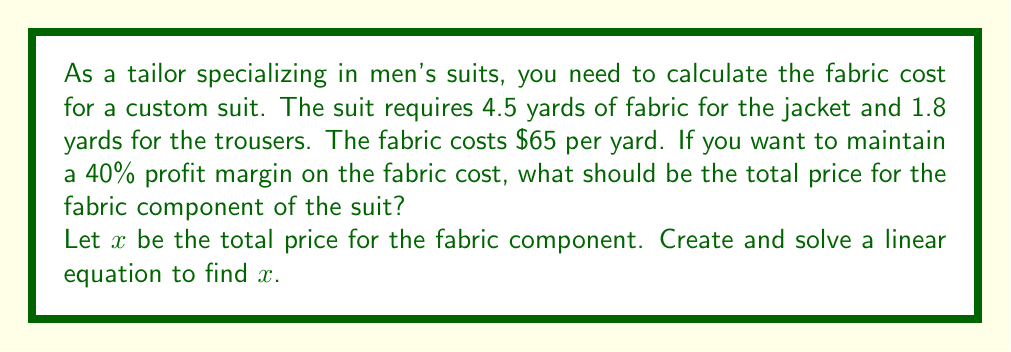What is the answer to this math problem? Let's approach this problem step-by-step:

1) First, calculate the total yardage of fabric needed:
   $4.5 + 1.8 = 6.3$ yards

2) Calculate the cost of the fabric:
   $6.3 \times $65 = $409.50$

3) Let $x$ be the total price for the fabric component. We know that the cost ($409.50) should represent 60% of the total price, as we want a 40% profit margin.

4) We can set up the following equation:
   $$409.50 = 0.60x$$

5) Solve for $x$:
   $$x = \frac{409.50}{0.60} = 682.50$$

Therefore, the total price for the fabric component should be $682.50.

To verify:
- Cost: $409.50
- Price: $682.50
- Profit: $682.50 - $409.50 = $273.00
- Profit margin: $\frac{273.00}{682.50} = 0.40$ or 40%
Answer: $682.50 